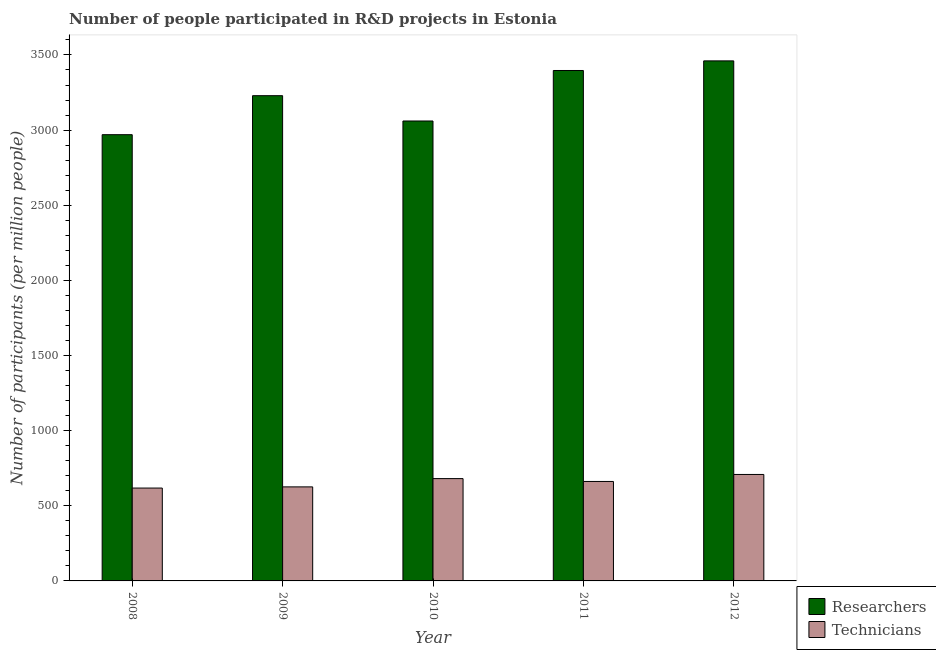How many different coloured bars are there?
Provide a succinct answer. 2. How many groups of bars are there?
Offer a very short reply. 5. Are the number of bars per tick equal to the number of legend labels?
Ensure brevity in your answer.  Yes. How many bars are there on the 5th tick from the right?
Ensure brevity in your answer.  2. In how many cases, is the number of bars for a given year not equal to the number of legend labels?
Offer a very short reply. 0. What is the number of technicians in 2010?
Your response must be concise. 680.89. Across all years, what is the maximum number of researchers?
Provide a short and direct response. 3460.62. Across all years, what is the minimum number of technicians?
Provide a succinct answer. 617.94. In which year was the number of technicians minimum?
Offer a very short reply. 2008. What is the total number of technicians in the graph?
Your answer should be compact. 3294.87. What is the difference between the number of technicians in 2008 and that in 2012?
Your answer should be compact. -90.5. What is the difference between the number of researchers in 2008 and the number of technicians in 2010?
Keep it short and to the point. -91.07. What is the average number of technicians per year?
Ensure brevity in your answer.  658.97. What is the ratio of the number of technicians in 2008 to that in 2011?
Your answer should be very brief. 0.93. What is the difference between the highest and the second highest number of technicians?
Offer a very short reply. 27.55. What is the difference between the highest and the lowest number of researchers?
Your response must be concise. 491.09. In how many years, is the number of technicians greater than the average number of technicians taken over all years?
Ensure brevity in your answer.  3. What does the 2nd bar from the left in 2010 represents?
Your answer should be compact. Technicians. What does the 1st bar from the right in 2012 represents?
Your answer should be very brief. Technicians. How many bars are there?
Offer a very short reply. 10. What is the difference between two consecutive major ticks on the Y-axis?
Ensure brevity in your answer.  500. Does the graph contain any zero values?
Keep it short and to the point. No. Where does the legend appear in the graph?
Ensure brevity in your answer.  Bottom right. How many legend labels are there?
Provide a succinct answer. 2. What is the title of the graph?
Provide a succinct answer. Number of people participated in R&D projects in Estonia. Does "All education staff compensation" appear as one of the legend labels in the graph?
Ensure brevity in your answer.  No. What is the label or title of the Y-axis?
Ensure brevity in your answer.  Number of participants (per million people). What is the Number of participants (per million people) in Researchers in 2008?
Keep it short and to the point. 2969.53. What is the Number of participants (per million people) of Technicians in 2008?
Ensure brevity in your answer.  617.94. What is the Number of participants (per million people) in Researchers in 2009?
Your response must be concise. 3229.01. What is the Number of participants (per million people) in Technicians in 2009?
Ensure brevity in your answer.  625.74. What is the Number of participants (per million people) of Researchers in 2010?
Provide a short and direct response. 3060.61. What is the Number of participants (per million people) of Technicians in 2010?
Offer a terse response. 680.89. What is the Number of participants (per million people) in Researchers in 2011?
Your answer should be compact. 3396.66. What is the Number of participants (per million people) of Technicians in 2011?
Offer a terse response. 661.86. What is the Number of participants (per million people) of Researchers in 2012?
Your response must be concise. 3460.62. What is the Number of participants (per million people) in Technicians in 2012?
Provide a short and direct response. 708.44. Across all years, what is the maximum Number of participants (per million people) of Researchers?
Give a very brief answer. 3460.62. Across all years, what is the maximum Number of participants (per million people) of Technicians?
Ensure brevity in your answer.  708.44. Across all years, what is the minimum Number of participants (per million people) of Researchers?
Provide a short and direct response. 2969.53. Across all years, what is the minimum Number of participants (per million people) in Technicians?
Your answer should be very brief. 617.94. What is the total Number of participants (per million people) of Researchers in the graph?
Your answer should be compact. 1.61e+04. What is the total Number of participants (per million people) in Technicians in the graph?
Ensure brevity in your answer.  3294.87. What is the difference between the Number of participants (per million people) of Researchers in 2008 and that in 2009?
Your answer should be very brief. -259.48. What is the difference between the Number of participants (per million people) in Technicians in 2008 and that in 2009?
Give a very brief answer. -7.8. What is the difference between the Number of participants (per million people) in Researchers in 2008 and that in 2010?
Provide a succinct answer. -91.07. What is the difference between the Number of participants (per million people) of Technicians in 2008 and that in 2010?
Offer a terse response. -62.95. What is the difference between the Number of participants (per million people) in Researchers in 2008 and that in 2011?
Your response must be concise. -427.13. What is the difference between the Number of participants (per million people) in Technicians in 2008 and that in 2011?
Keep it short and to the point. -43.93. What is the difference between the Number of participants (per million people) of Researchers in 2008 and that in 2012?
Provide a short and direct response. -491.09. What is the difference between the Number of participants (per million people) in Technicians in 2008 and that in 2012?
Keep it short and to the point. -90.5. What is the difference between the Number of participants (per million people) of Researchers in 2009 and that in 2010?
Give a very brief answer. 168.4. What is the difference between the Number of participants (per million people) in Technicians in 2009 and that in 2010?
Make the answer very short. -55.14. What is the difference between the Number of participants (per million people) in Researchers in 2009 and that in 2011?
Keep it short and to the point. -167.65. What is the difference between the Number of participants (per million people) of Technicians in 2009 and that in 2011?
Your answer should be very brief. -36.12. What is the difference between the Number of participants (per million people) in Researchers in 2009 and that in 2012?
Your response must be concise. -231.61. What is the difference between the Number of participants (per million people) in Technicians in 2009 and that in 2012?
Provide a short and direct response. -82.7. What is the difference between the Number of participants (per million people) of Researchers in 2010 and that in 2011?
Your response must be concise. -336.06. What is the difference between the Number of participants (per million people) of Technicians in 2010 and that in 2011?
Ensure brevity in your answer.  19.02. What is the difference between the Number of participants (per million people) in Researchers in 2010 and that in 2012?
Ensure brevity in your answer.  -400.01. What is the difference between the Number of participants (per million people) of Technicians in 2010 and that in 2012?
Provide a succinct answer. -27.55. What is the difference between the Number of participants (per million people) of Researchers in 2011 and that in 2012?
Make the answer very short. -63.96. What is the difference between the Number of participants (per million people) in Technicians in 2011 and that in 2012?
Keep it short and to the point. -46.57. What is the difference between the Number of participants (per million people) in Researchers in 2008 and the Number of participants (per million people) in Technicians in 2009?
Keep it short and to the point. 2343.79. What is the difference between the Number of participants (per million people) of Researchers in 2008 and the Number of participants (per million people) of Technicians in 2010?
Make the answer very short. 2288.65. What is the difference between the Number of participants (per million people) of Researchers in 2008 and the Number of participants (per million people) of Technicians in 2011?
Your answer should be very brief. 2307.67. What is the difference between the Number of participants (per million people) of Researchers in 2008 and the Number of participants (per million people) of Technicians in 2012?
Ensure brevity in your answer.  2261.1. What is the difference between the Number of participants (per million people) of Researchers in 2009 and the Number of participants (per million people) of Technicians in 2010?
Make the answer very short. 2548.13. What is the difference between the Number of participants (per million people) of Researchers in 2009 and the Number of participants (per million people) of Technicians in 2011?
Your answer should be very brief. 2567.15. What is the difference between the Number of participants (per million people) in Researchers in 2009 and the Number of participants (per million people) in Technicians in 2012?
Your answer should be very brief. 2520.57. What is the difference between the Number of participants (per million people) in Researchers in 2010 and the Number of participants (per million people) in Technicians in 2011?
Your answer should be compact. 2398.74. What is the difference between the Number of participants (per million people) in Researchers in 2010 and the Number of participants (per million people) in Technicians in 2012?
Ensure brevity in your answer.  2352.17. What is the difference between the Number of participants (per million people) of Researchers in 2011 and the Number of participants (per million people) of Technicians in 2012?
Your answer should be compact. 2688.23. What is the average Number of participants (per million people) of Researchers per year?
Your answer should be very brief. 3223.29. What is the average Number of participants (per million people) in Technicians per year?
Your answer should be compact. 658.97. In the year 2008, what is the difference between the Number of participants (per million people) in Researchers and Number of participants (per million people) in Technicians?
Your answer should be very brief. 2351.6. In the year 2009, what is the difference between the Number of participants (per million people) in Researchers and Number of participants (per million people) in Technicians?
Provide a short and direct response. 2603.27. In the year 2010, what is the difference between the Number of participants (per million people) of Researchers and Number of participants (per million people) of Technicians?
Offer a very short reply. 2379.72. In the year 2011, what is the difference between the Number of participants (per million people) of Researchers and Number of participants (per million people) of Technicians?
Make the answer very short. 2734.8. In the year 2012, what is the difference between the Number of participants (per million people) of Researchers and Number of participants (per million people) of Technicians?
Your answer should be very brief. 2752.18. What is the ratio of the Number of participants (per million people) of Researchers in 2008 to that in 2009?
Make the answer very short. 0.92. What is the ratio of the Number of participants (per million people) of Technicians in 2008 to that in 2009?
Keep it short and to the point. 0.99. What is the ratio of the Number of participants (per million people) of Researchers in 2008 to that in 2010?
Give a very brief answer. 0.97. What is the ratio of the Number of participants (per million people) in Technicians in 2008 to that in 2010?
Offer a terse response. 0.91. What is the ratio of the Number of participants (per million people) in Researchers in 2008 to that in 2011?
Ensure brevity in your answer.  0.87. What is the ratio of the Number of participants (per million people) of Technicians in 2008 to that in 2011?
Your response must be concise. 0.93. What is the ratio of the Number of participants (per million people) in Researchers in 2008 to that in 2012?
Ensure brevity in your answer.  0.86. What is the ratio of the Number of participants (per million people) of Technicians in 2008 to that in 2012?
Provide a short and direct response. 0.87. What is the ratio of the Number of participants (per million people) in Researchers in 2009 to that in 2010?
Keep it short and to the point. 1.05. What is the ratio of the Number of participants (per million people) in Technicians in 2009 to that in 2010?
Offer a terse response. 0.92. What is the ratio of the Number of participants (per million people) of Researchers in 2009 to that in 2011?
Provide a short and direct response. 0.95. What is the ratio of the Number of participants (per million people) in Technicians in 2009 to that in 2011?
Ensure brevity in your answer.  0.95. What is the ratio of the Number of participants (per million people) in Researchers in 2009 to that in 2012?
Give a very brief answer. 0.93. What is the ratio of the Number of participants (per million people) in Technicians in 2009 to that in 2012?
Provide a short and direct response. 0.88. What is the ratio of the Number of participants (per million people) in Researchers in 2010 to that in 2011?
Make the answer very short. 0.9. What is the ratio of the Number of participants (per million people) of Technicians in 2010 to that in 2011?
Your answer should be very brief. 1.03. What is the ratio of the Number of participants (per million people) of Researchers in 2010 to that in 2012?
Make the answer very short. 0.88. What is the ratio of the Number of participants (per million people) of Technicians in 2010 to that in 2012?
Provide a succinct answer. 0.96. What is the ratio of the Number of participants (per million people) in Researchers in 2011 to that in 2012?
Give a very brief answer. 0.98. What is the ratio of the Number of participants (per million people) of Technicians in 2011 to that in 2012?
Your answer should be compact. 0.93. What is the difference between the highest and the second highest Number of participants (per million people) in Researchers?
Offer a terse response. 63.96. What is the difference between the highest and the second highest Number of participants (per million people) in Technicians?
Keep it short and to the point. 27.55. What is the difference between the highest and the lowest Number of participants (per million people) in Researchers?
Give a very brief answer. 491.09. What is the difference between the highest and the lowest Number of participants (per million people) of Technicians?
Make the answer very short. 90.5. 